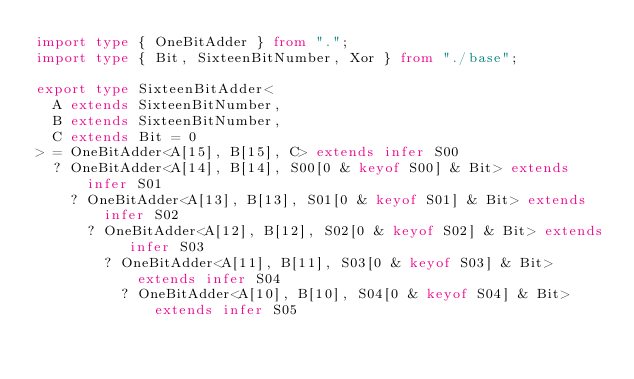<code> <loc_0><loc_0><loc_500><loc_500><_TypeScript_>import type { OneBitAdder } from ".";
import type { Bit, SixteenBitNumber, Xor } from "./base";

export type SixteenBitAdder<
  A extends SixteenBitNumber, 
  B extends SixteenBitNumber,
  C extends Bit = 0
> = OneBitAdder<A[15], B[15], C> extends infer S00
  ? OneBitAdder<A[14], B[14], S00[0 & keyof S00] & Bit> extends infer S01
    ? OneBitAdder<A[13], B[13], S01[0 & keyof S01] & Bit> extends infer S02
      ? OneBitAdder<A[12], B[12], S02[0 & keyof S02] & Bit> extends infer S03
        ? OneBitAdder<A[11], B[11], S03[0 & keyof S03] & Bit> extends infer S04
          ? OneBitAdder<A[10], B[10], S04[0 & keyof S04] & Bit> extends infer S05</code> 